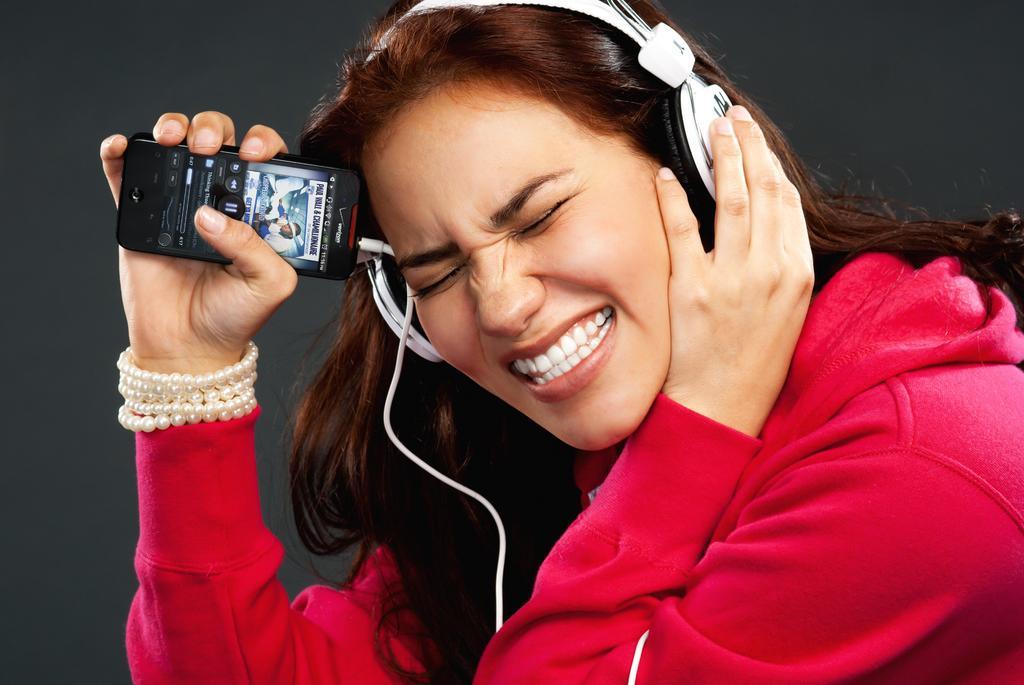Describe this image in one or two sentences. In this image I can see a girl is wearing a headphone. I can also see she is holding a phone. Here I can see she is wearing a red color of hoodie. 